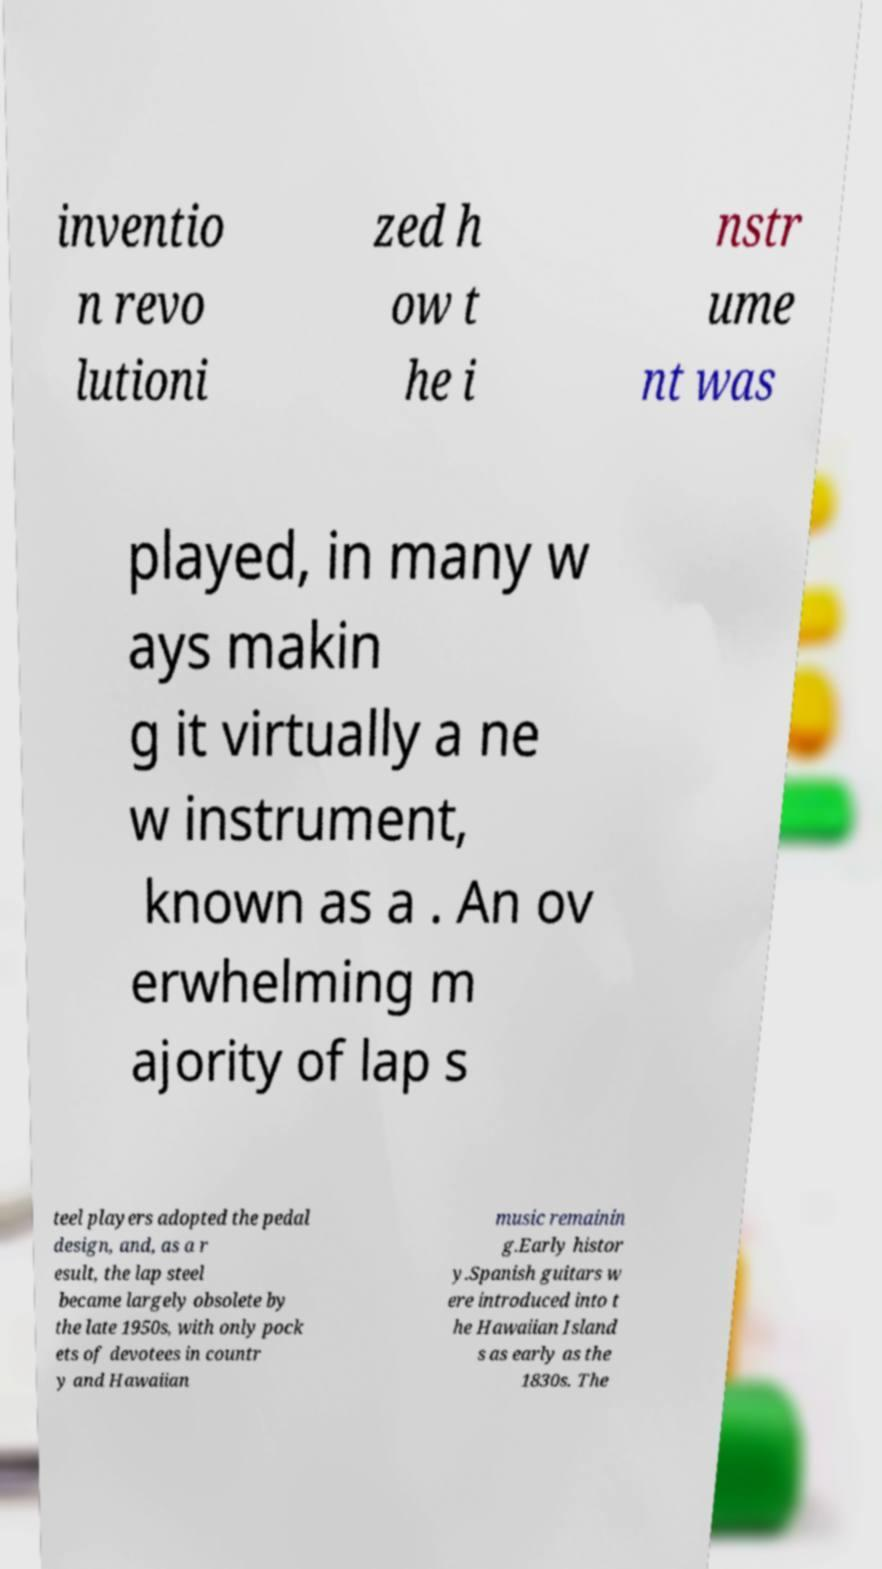Can you read and provide the text displayed in the image?This photo seems to have some interesting text. Can you extract and type it out for me? inventio n revo lutioni zed h ow t he i nstr ume nt was played, in many w ays makin g it virtually a ne w instrument, known as a . An ov erwhelming m ajority of lap s teel players adopted the pedal design, and, as a r esult, the lap steel became largely obsolete by the late 1950s, with only pock ets of devotees in countr y and Hawaiian music remainin g.Early histor y.Spanish guitars w ere introduced into t he Hawaiian Island s as early as the 1830s. The 